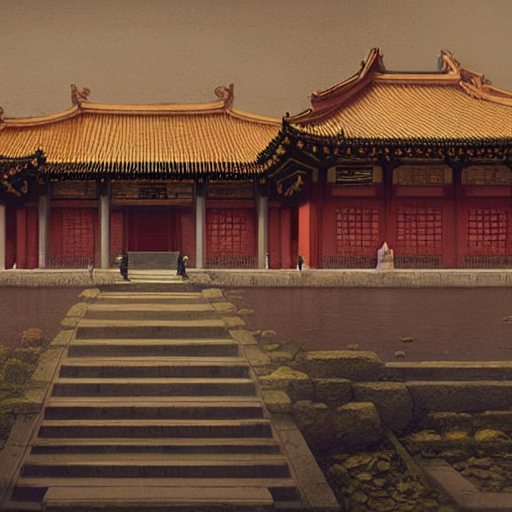If this were a scene from a story, what kind of narrative could be taking place? Given the grandeur and traditional setting of this scene, one could imagine a historical drama unfolding within its walls. The narrative might revolve around the complexities of court life, with storylines of political intrigue, philosophical debates, or romantic liaisons. The emptiness of the courtyards juxtaposed against the might of the architecture could also suggest themes of loneliness within power or the quiet moments before a significant event occurs in the story. 